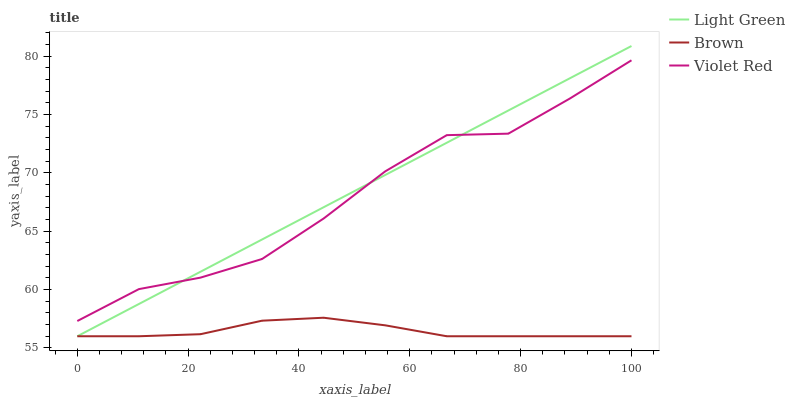Does Brown have the minimum area under the curve?
Answer yes or no. Yes. Does Light Green have the maximum area under the curve?
Answer yes or no. Yes. Does Violet Red have the minimum area under the curve?
Answer yes or no. No. Does Violet Red have the maximum area under the curve?
Answer yes or no. No. Is Light Green the smoothest?
Answer yes or no. Yes. Is Violet Red the roughest?
Answer yes or no. Yes. Is Violet Red the smoothest?
Answer yes or no. No. Is Light Green the roughest?
Answer yes or no. No. Does Brown have the lowest value?
Answer yes or no. Yes. Does Violet Red have the lowest value?
Answer yes or no. No. Does Light Green have the highest value?
Answer yes or no. Yes. Does Violet Red have the highest value?
Answer yes or no. No. Is Brown less than Violet Red?
Answer yes or no. Yes. Is Violet Red greater than Brown?
Answer yes or no. Yes. Does Light Green intersect Brown?
Answer yes or no. Yes. Is Light Green less than Brown?
Answer yes or no. No. Is Light Green greater than Brown?
Answer yes or no. No. Does Brown intersect Violet Red?
Answer yes or no. No. 